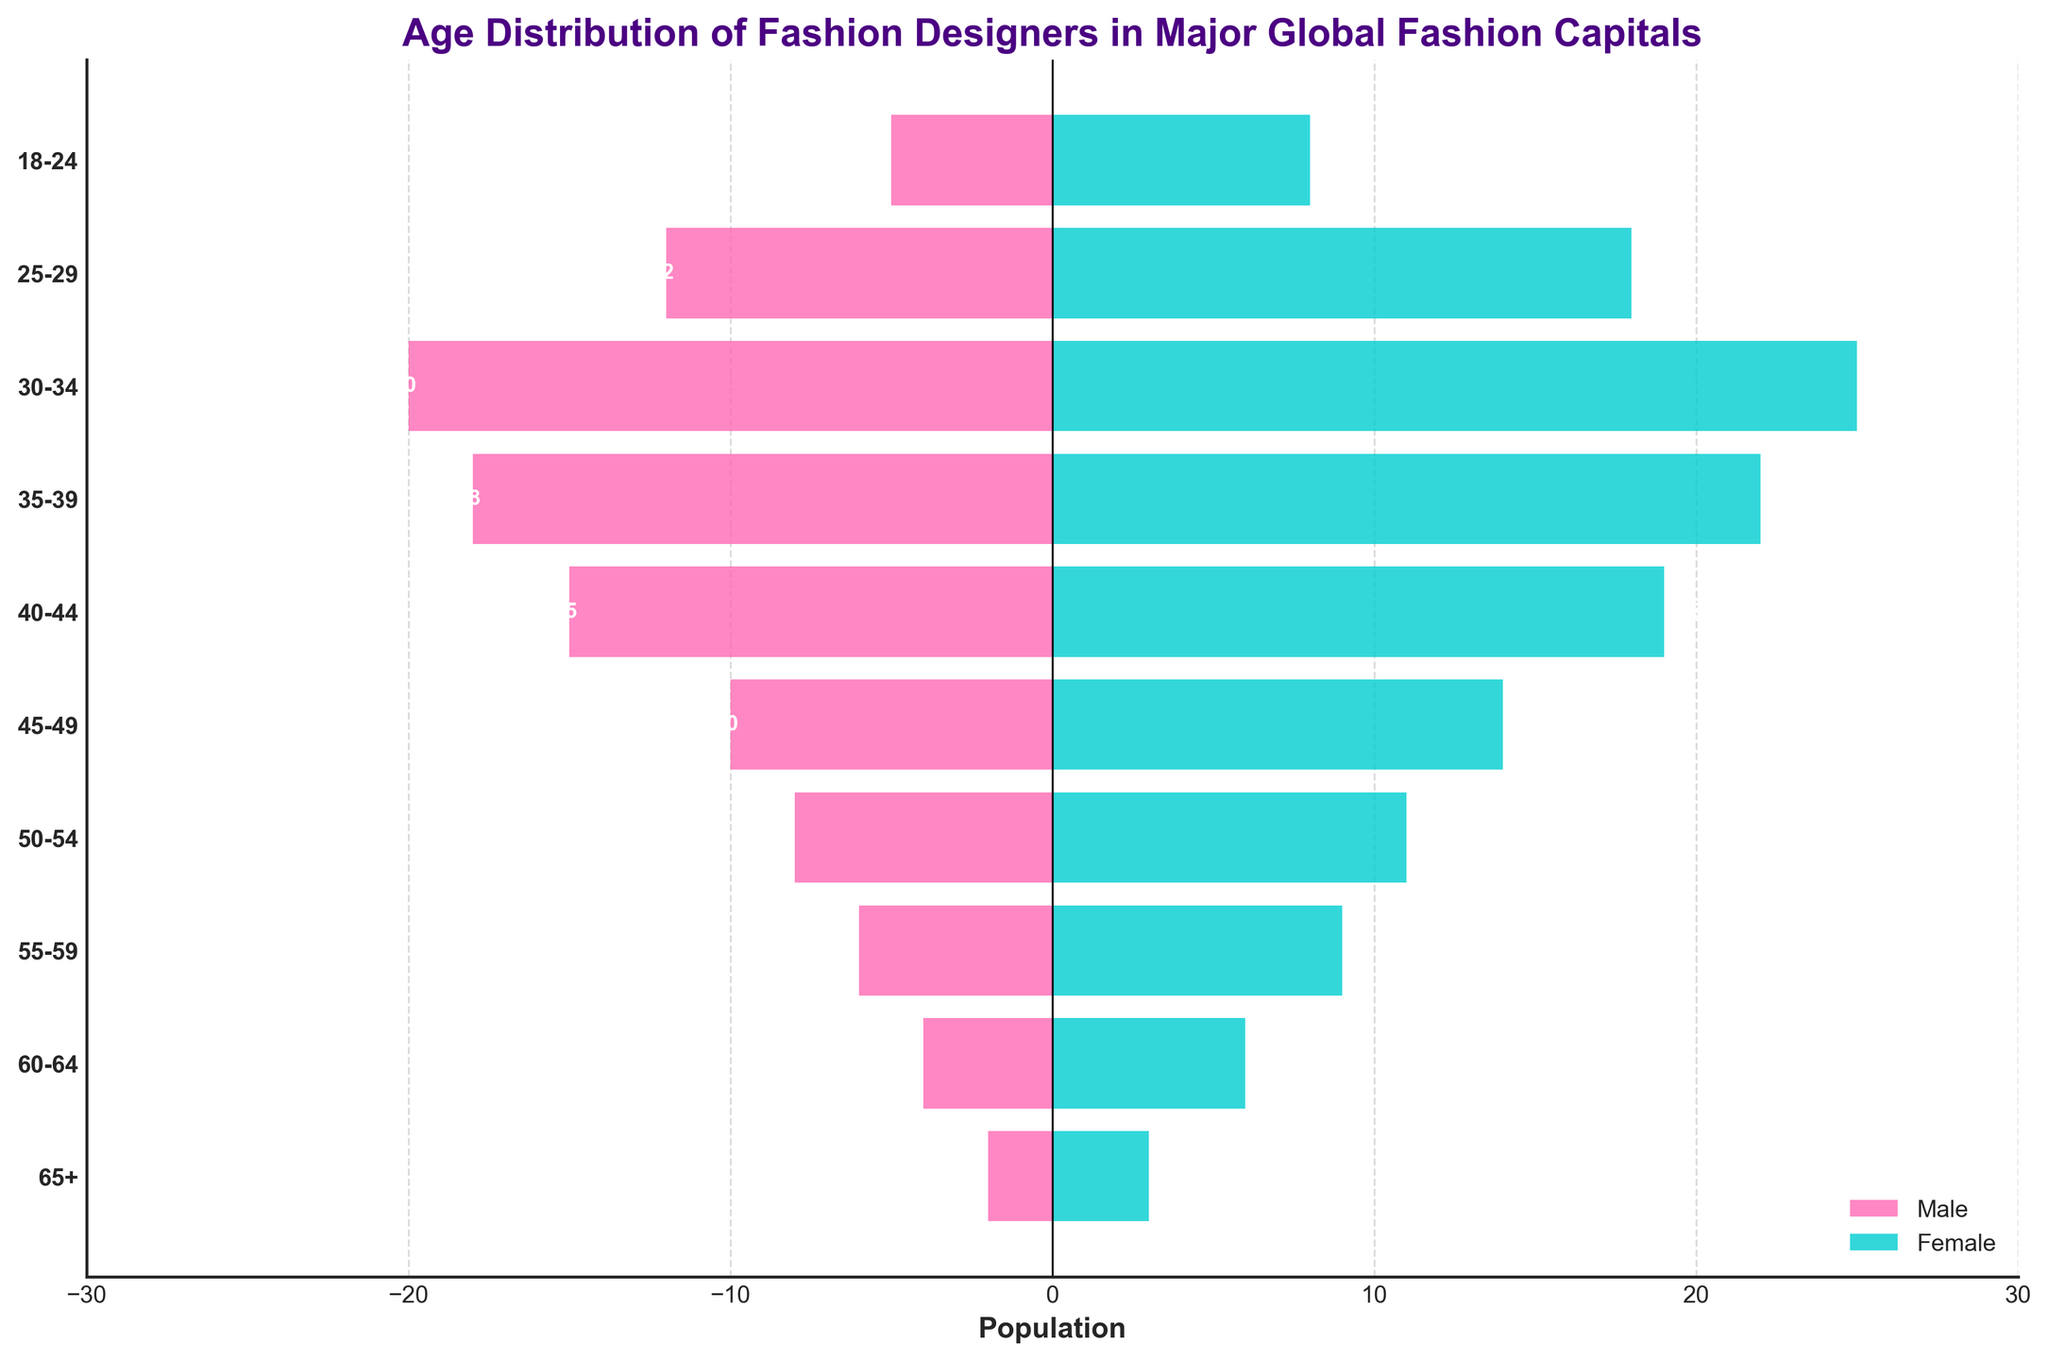What is the title of the figure? The title of the figure is written at the top and it summarizes the main topic of the chart.
Answer: Age Distribution of Fashion Designers in Major Global Fashion Capitals Which age group has the highest number of female fashion designers? For females, the highest bar corresponds to the age group 30-34, indicating the largest population in that group.
Answer: 30-34 How many male and female fashion designers are in the age group 40-44? The bars for the age group 40-44 show 15 males and 19 females.
Answer: 15 males and 19 females What is the total number of fashion designers (both male and female) in the age group 25-29? Adding the numbers for males and females in the age group 25-29, we get 12 (male) + 18 (female) = 30.
Answer: 30 Which age group has the smallest number of male fashion designers? The smallest bar for males corresponds to the age group 65+, indicating the fewest number of males in that group.
Answer: 65+ Compare the number of male and female fashion designers in the age group 50-54. Which gender has more, and by how many? There are 8 males and 11 females in the age group 50-54. Comparing these numbers, females have 3 more designers than males.
Answer: Females have 3 more What is the age group with the most balanced number of male and female fashion designers? By comparing the lengths of the bars, the age group 55-59 shows 6 males and 9 females, which is a close balance compared to other groups.
Answer: 55-59 How many more female than male fashion designers are in the age group 35-39? There are 22 females and 18 males in the age group 35-39. The difference is 22 - 18 = 4 more females.
Answer: 4 more females What is the age group that has the highest combined (male and female) population of fashion designers? By examining the bars, the age group 30-34 has the highest combined number of fashion designers (20 males and 25 females).
Answer: 30-34 What's the average number of fashion designers per gender in the age group 18-24? The age group 18-24 has 5 males and 8 females. The average for males is 5 / 1 = 5, and for females is 8 / 1 = 8.
Answer: 5 males, 8 females 